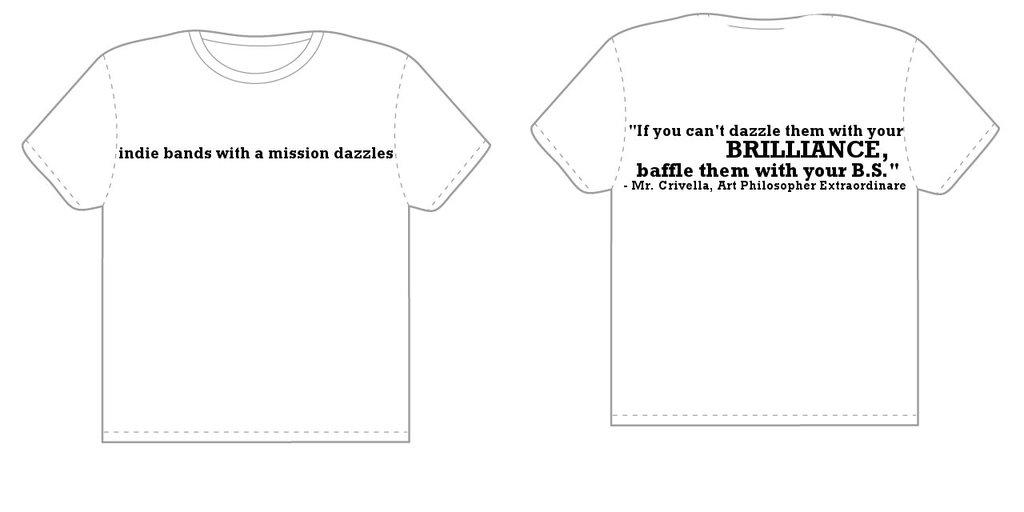<image>
Summarize the visual content of the image. a shirt that has the word brilliance on it 